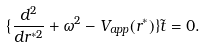<formula> <loc_0><loc_0><loc_500><loc_500>\{ \frac { d ^ { 2 } } { d r ^ { * 2 } } + \omega ^ { 2 } - V _ { a p p } ( r ^ { * } ) \} \tilde { t } = 0 .</formula> 